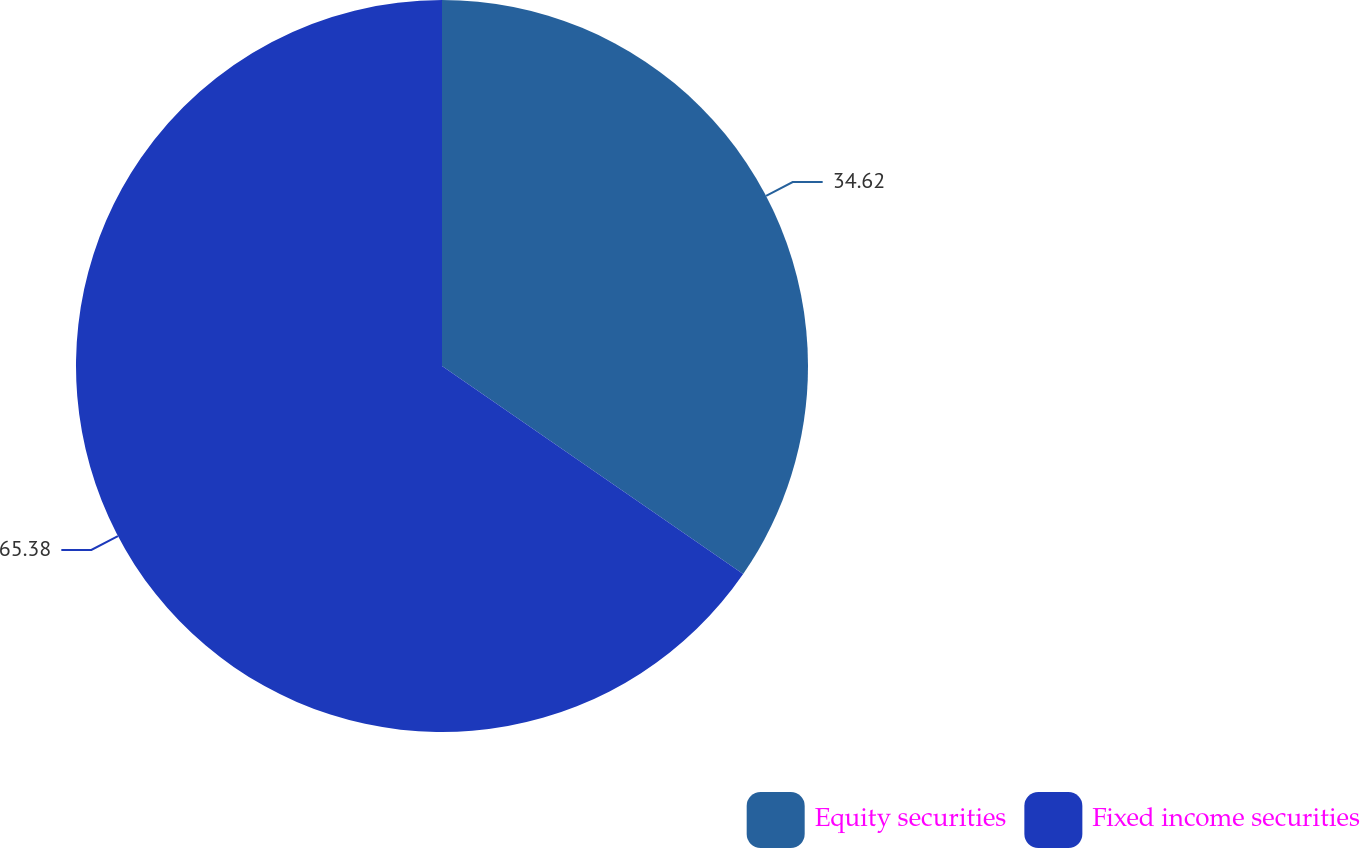Convert chart. <chart><loc_0><loc_0><loc_500><loc_500><pie_chart><fcel>Equity securities<fcel>Fixed income securities<nl><fcel>34.62%<fcel>65.38%<nl></chart> 